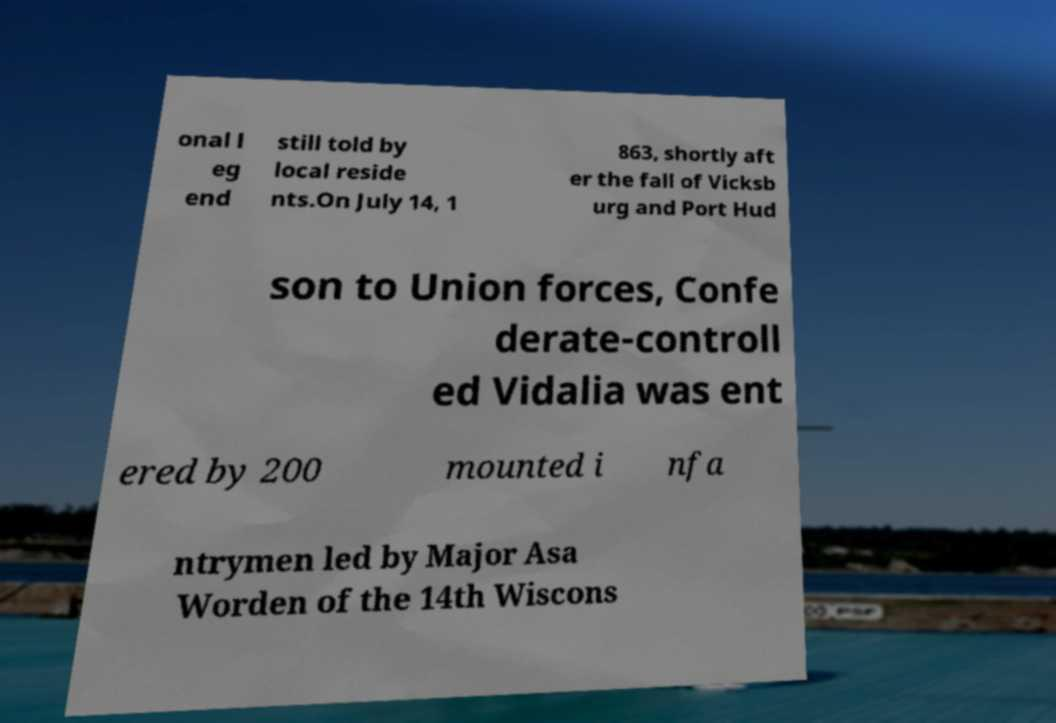I need the written content from this picture converted into text. Can you do that? onal l eg end still told by local reside nts.On July 14, 1 863, shortly aft er the fall of Vicksb urg and Port Hud son to Union forces, Confe derate-controll ed Vidalia was ent ered by 200 mounted i nfa ntrymen led by Major Asa Worden of the 14th Wiscons 